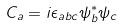Convert formula to latex. <formula><loc_0><loc_0><loc_500><loc_500>C _ { a } = i \epsilon _ { a b c } \psi ^ { * } _ { b } \psi _ { c }</formula> 